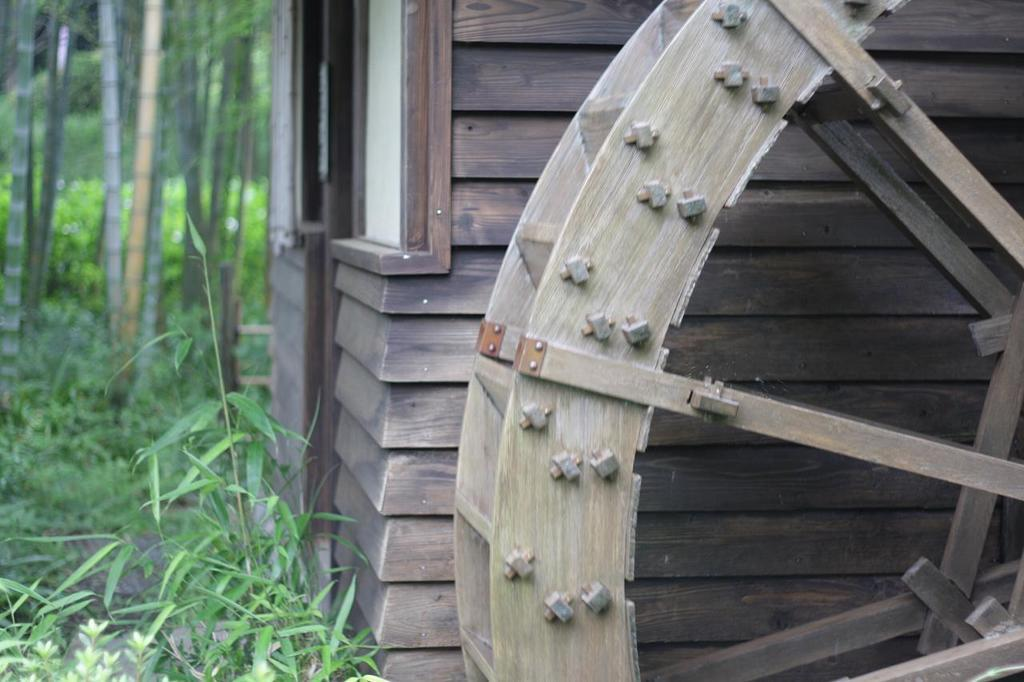What type of structure is in the picture? There is a house in the picture. What object can be seen on the right side of the picture? There is a wooden wheel on the right side of the picture. What type of vegetation is at the bottom of the picture? There are plants at the bottom of the picture. What can be seen in the background of the picture? There are trees visible in the background of the picture. What type of emotion is the house displaying in the picture? The house is an inanimate object and cannot display emotions like anger. 